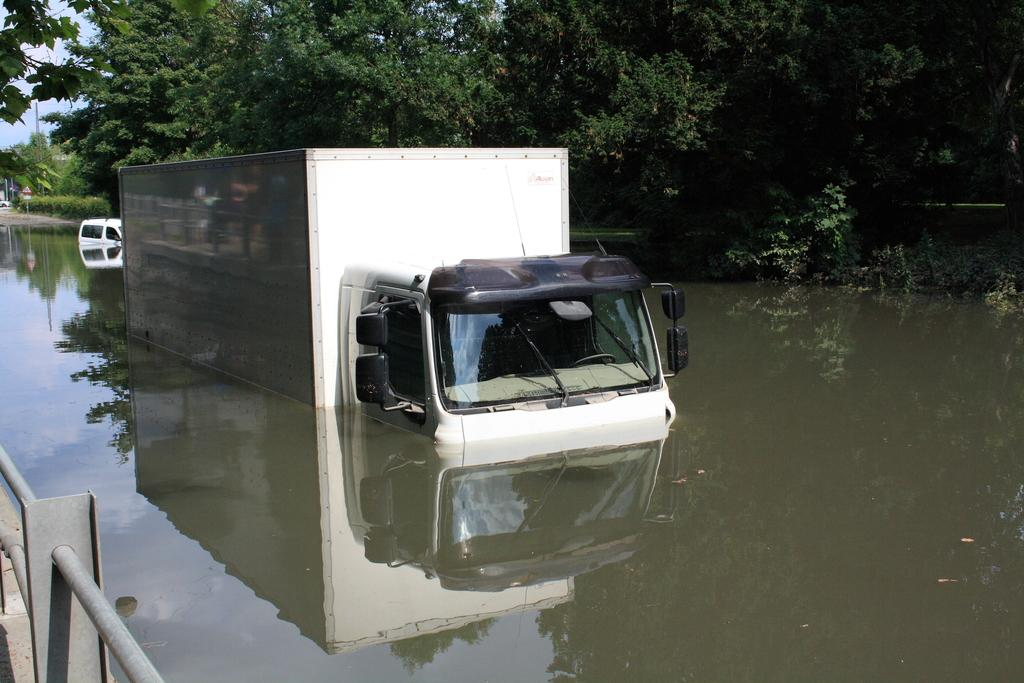What is the main subject of the image? The main subject of the image is a truck in the water. Are there any other objects or structures in the image? Yes, there is a railing in the left corner of the image and another vehicle in the water. What can be seen in the background of the image? In the background, there are trees and the sky visible. What type of shock can be seen affecting the trees in the image? There is no shock present in the image, and the trees are not affected by any shock. 